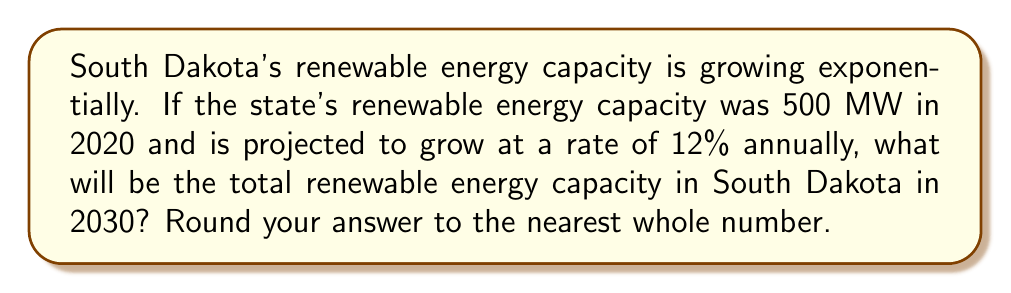Show me your answer to this math problem. Let's approach this step-by-step using an exponential growth function:

1) The general form of an exponential growth function is:
   $$A(t) = A_0(1 + r)^t$$
   Where:
   $A(t)$ is the amount after time $t$
   $A_0$ is the initial amount
   $r$ is the growth rate (as a decimal)
   $t$ is the time period

2) Given:
   $A_0 = 500$ MW (initial capacity in 2020)
   $r = 0.12$ (12% annual growth rate)
   $t = 10$ years (from 2020 to 2030)

3) Plugging these values into our equation:
   $$A(10) = 500(1 + 0.12)^{10}$$

4) Simplify:
   $$A(10) = 500(1.12)^{10}$$

5) Calculate:
   $$A(10) = 500 * 3.1058 = 1552.9 \text{ MW}$$

6) Rounding to the nearest whole number:
   $$A(10) \approx 1553 \text{ MW}$$

Therefore, the total renewable energy capacity in South Dakota in 2030 will be approximately 1553 MW.
Answer: 1553 MW 